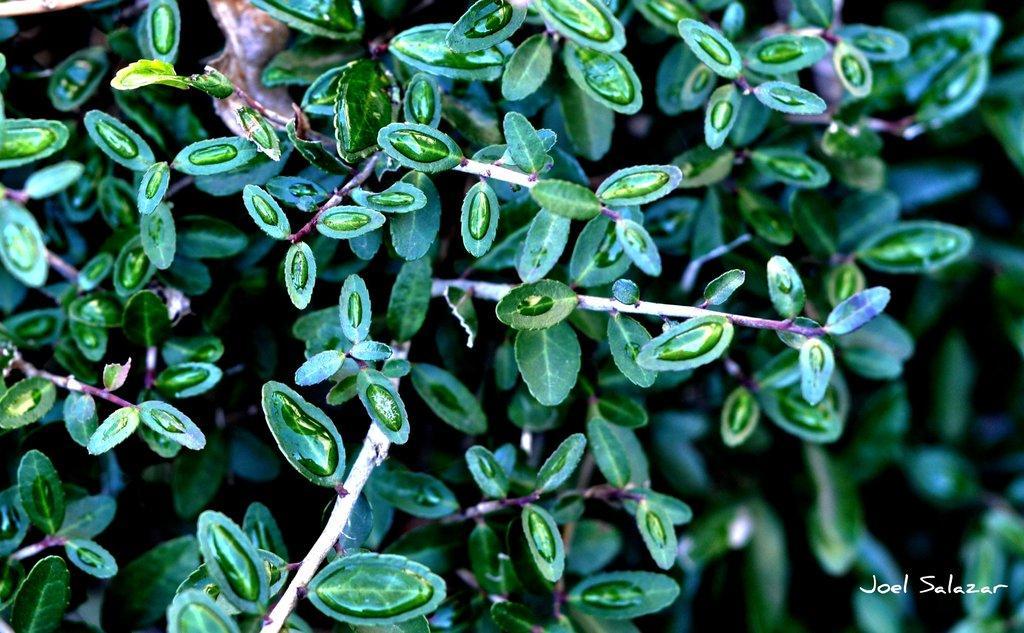Please provide a concise description of this image. In this image we can see a plant with water droplets on it. The background of the image is slightly blurred. Here we can see some edited text. 